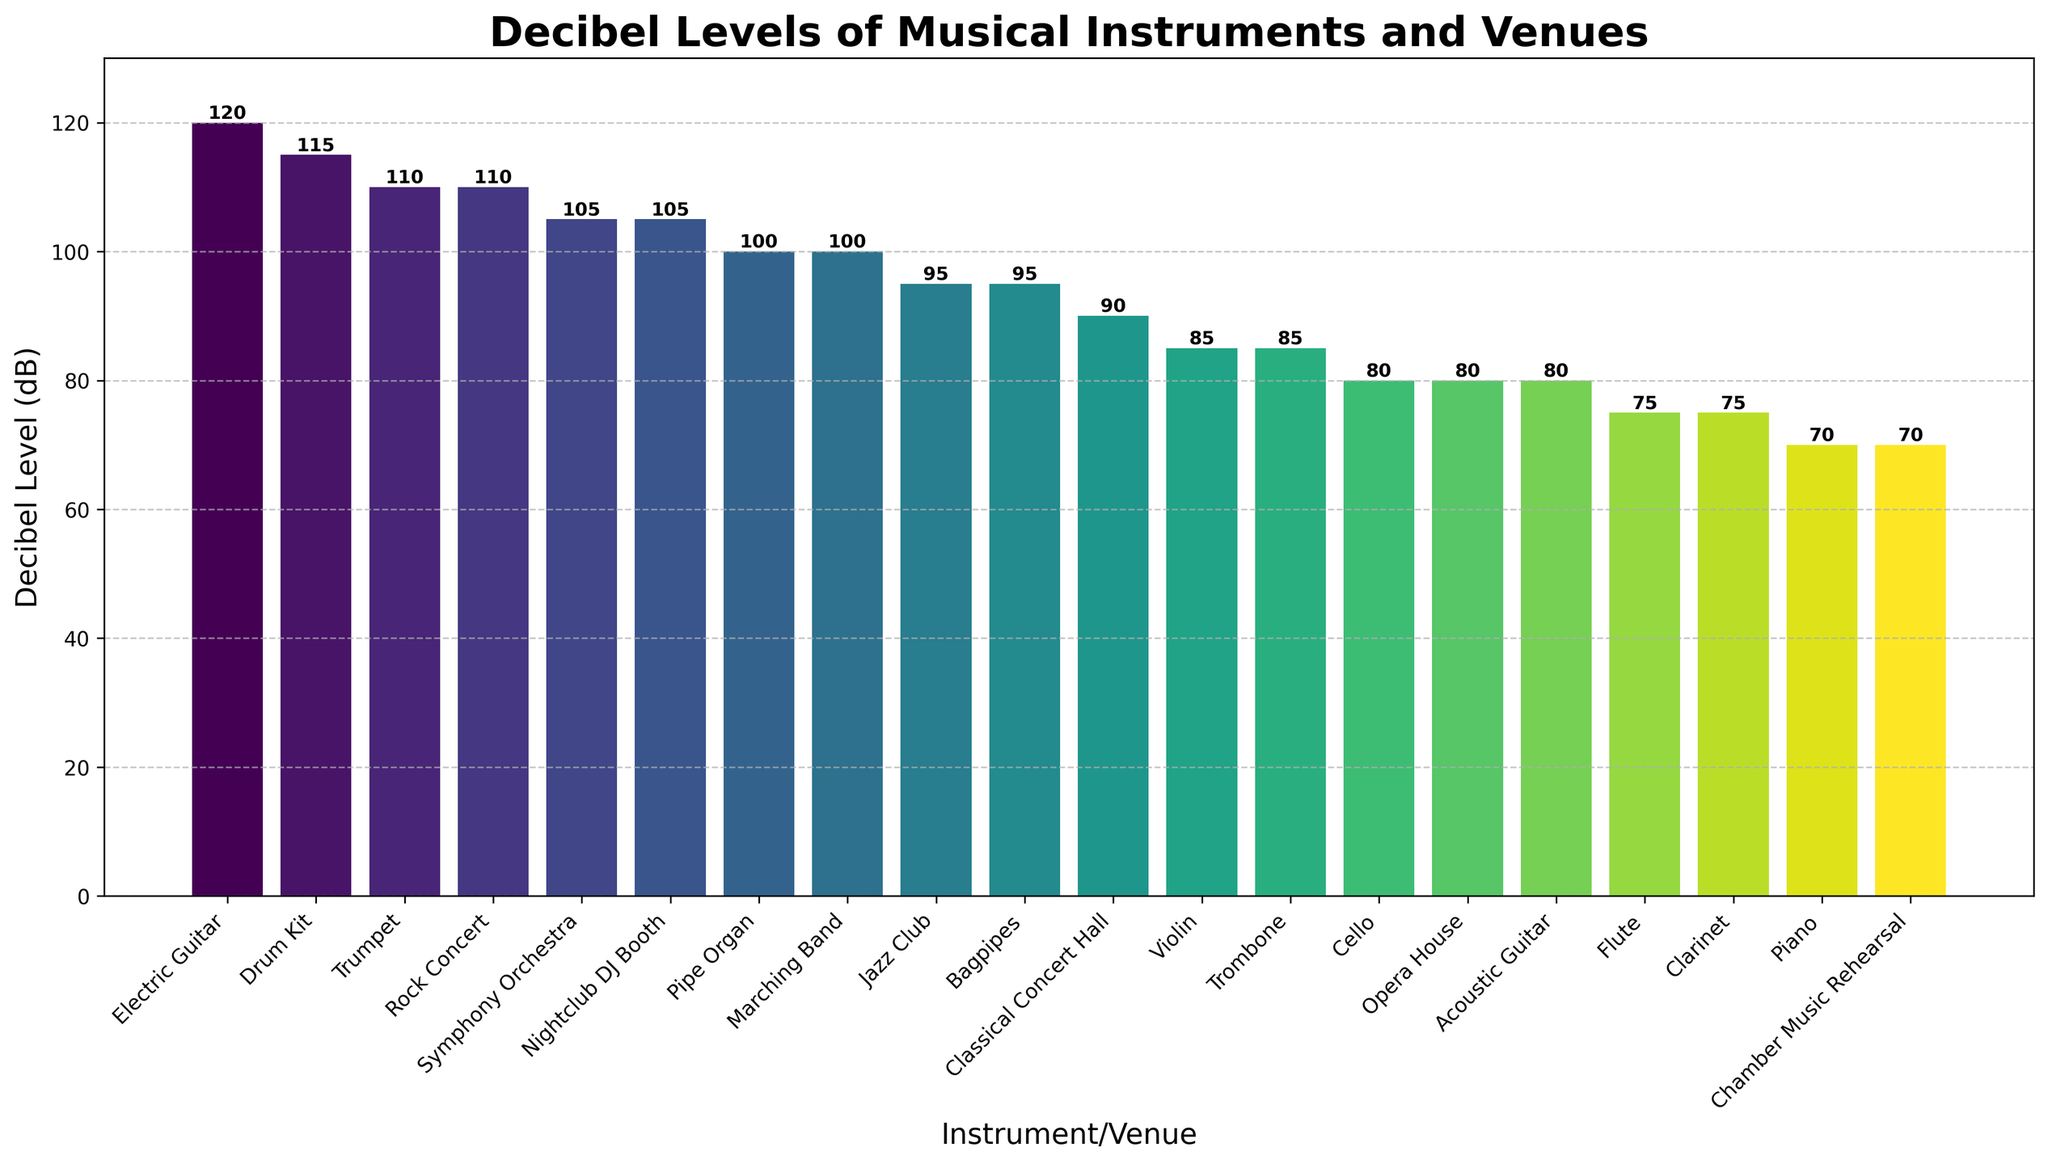Which instrument has the highest decibel level? The tallest bar represents the Electric Guitar with the highest decibel level of 120 dB, indicated at the top of its bar.
Answer: Electric Guitar Which venue has lower decibel levels, Opera House or Nightclub DJ Booth? By comparing the heights of the bars for Opera House and Nightclub DJ Booth, Opera House is at 80 dB while Nightclub DJ Booth reaches 105 dB. Thus, Opera House is lower.
Answer: Opera House What is the decibel difference between the Drum Kit and the Flute? The drum kit has a decibel level of 115 dB, while the flute is at 75 dB. The difference is calculated as 115 dB - 75 dB.
Answer: 40 dB Which has a higher decibel level, Jazz Club or Classical Concert Hall? By comparing the heights of the bars, Jazz Club is at 95 dB, and Classical Concert Hall is at 90 dB. Thus, Jazz Club is higher.
Answer: Jazz Club What is the average decibel level of Flute, Piano, and Clarinet? The decibel levels for Flute, Piano, and Clarinet are 75 dB, 70 dB, and 75 dB, respectively. The average is calculated as (75 + 70 + 75) / 3.
Answer: 73.3 dB Identify the instrument with the second-highest decibel level and state its value. The second tallest bar, after the Electric Guitar (120 dB), represents the Drum Kit with a decibel level of 115 dB.
Answer: Drum Kit, 115 dB How many instruments/venues have a decibel level equal to or greater than 100 dB? Instruments/Venues at or above 100 dB are Electric Guitar (120 dB), Drum Kit (115 dB), Trumpet (110 dB), Rock Concert (110 dB), Symphony Orchestra (105 dB), Nightclub DJ Booth (105 dB), Marching Band (100 dB), and Pipe Organ (100 dB). There are 8 of them.
Answer: 8 Which three instruments/venues have the closest decibel levels to each other? The closest decibel levels are the Trumpet, Rock Concert, and Symphony Orchestra, all around 105-110 dB, with very similar bar heights.
Answer: Trumpet, Rock Concert, Symphony Orchestra Which instrument/venue has a lower decibel level, Cello or Trombone? By comparing the heights of the bars, Cello has a decibel level of 80 dB while Trombone is at 85 dB. Thus, Cello is lower.
Answer: Cello 